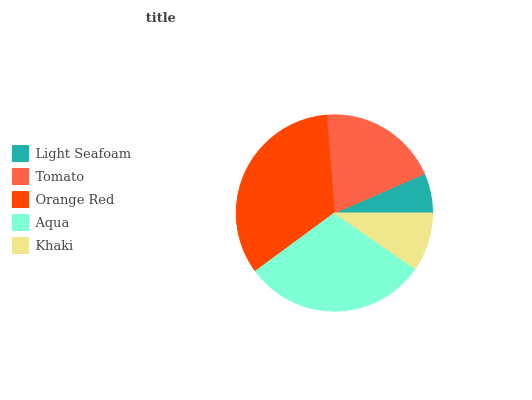Is Light Seafoam the minimum?
Answer yes or no. Yes. Is Orange Red the maximum?
Answer yes or no. Yes. Is Tomato the minimum?
Answer yes or no. No. Is Tomato the maximum?
Answer yes or no. No. Is Tomato greater than Light Seafoam?
Answer yes or no. Yes. Is Light Seafoam less than Tomato?
Answer yes or no. Yes. Is Light Seafoam greater than Tomato?
Answer yes or no. No. Is Tomato less than Light Seafoam?
Answer yes or no. No. Is Tomato the high median?
Answer yes or no. Yes. Is Tomato the low median?
Answer yes or no. Yes. Is Orange Red the high median?
Answer yes or no. No. Is Light Seafoam the low median?
Answer yes or no. No. 